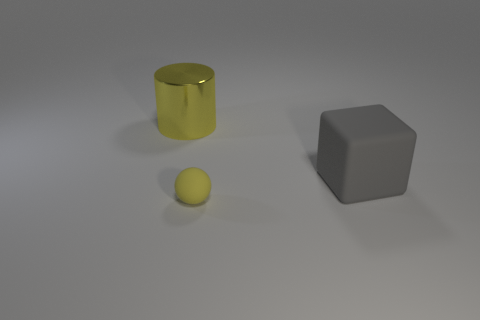Add 3 cyan balls. How many objects exist? 6 Subtract all cylinders. How many objects are left? 2 Add 3 small brown balls. How many small brown balls exist? 3 Subtract 0 blue balls. How many objects are left? 3 Subtract all shiny cylinders. Subtract all gray blocks. How many objects are left? 1 Add 3 large yellow things. How many large yellow things are left? 4 